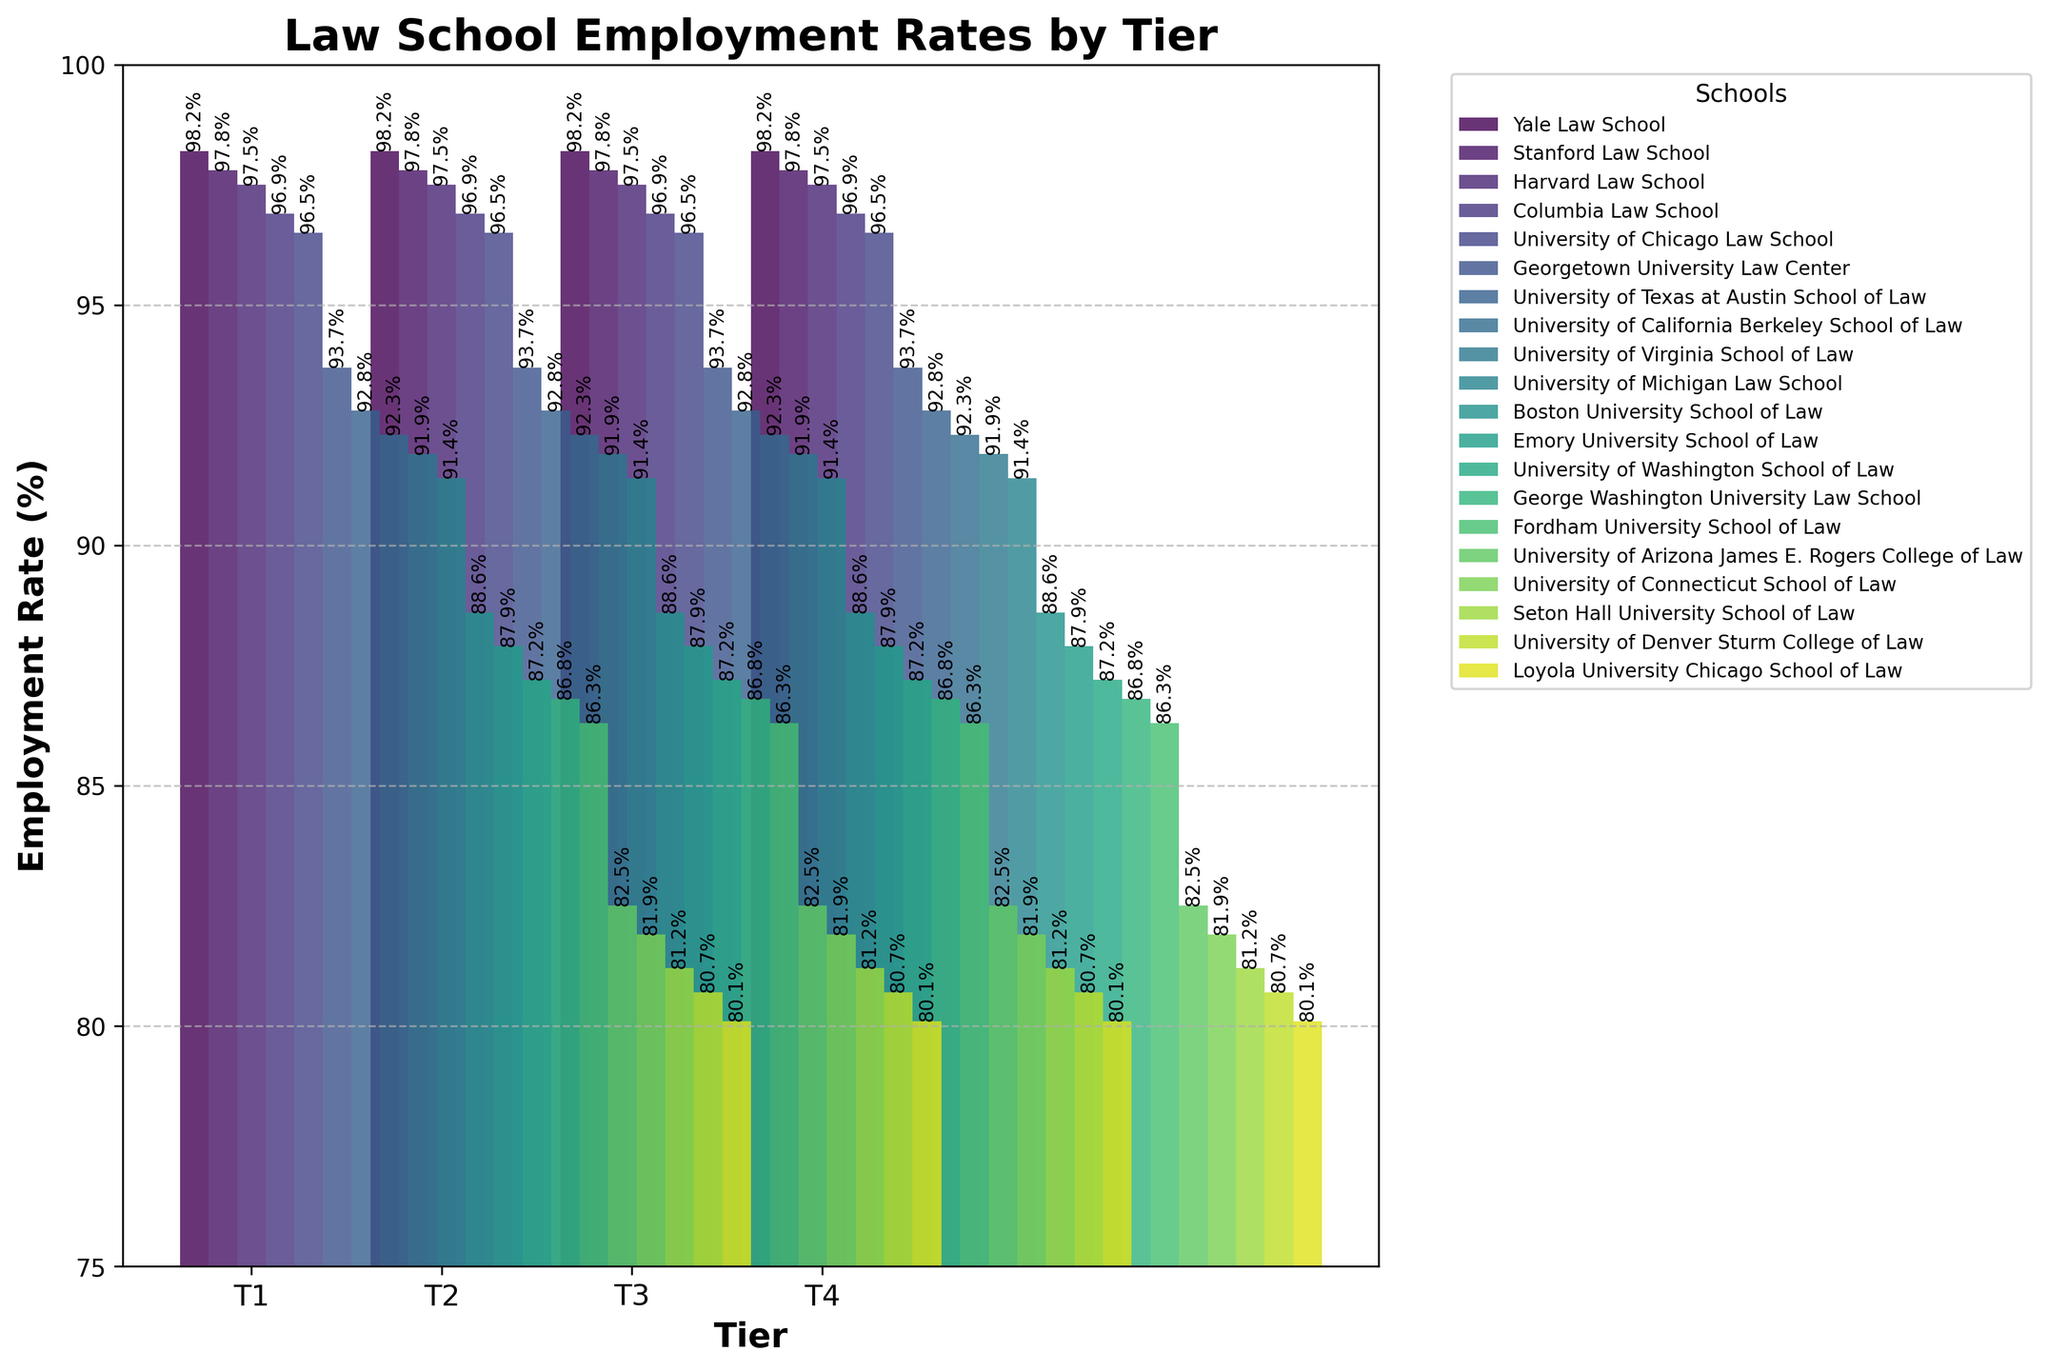What is the employment rate of Harvard Law School? Identify the bar labeled "Harvard Law School" on the x-axis under Tier 1 and read the employment rate from the y-axis.
Answer: 97.5% Which law school in Tier 2 has the highest employment rate? Look at the bars corresponding to Tier 2 and identify the tallest bar. Georgetown University Law Center has the highest employment rate in Tier 2.
Answer: Georgetown University Law Center Is the average employment rate of Tier 3 schools greater than 87%? Calculate the average employment rate of Tier 3 schools by adding their rates and dividing by the number of schools: (88.6 + 87.9 + 87.2 + 86.8 + 86.3) / 5 = 87.36. Compare this with 87%.
Answer: Yes How does the employment rate of Yale Law School compare to that of Stanford Law School? Identify the bars for Yale Law School and Stanford Law School in Tier 1 and compare their heights or the values from the y-axis. Yale Law School has a higher employment rate.
Answer: Yale Law School has a higher rate What is the range of employment rates for schools in Tier 4? Identify the lowest and highest employment rates among Tier 4 schools. The lowest rate is Loyola University Chicago School of Law (80.1) and the highest is University of Arizona James E. Rogers College of Law (82.5). The range is 82.5 - 80.1 = 2.4.
Answer: 2.4 Which tier has the most schools with an employment rate above 90%? Count the number of schools in each tier whose bars reach above the 90% mark on the y-axis. Tier 1 has all five schools above 90%, and Tier 2 has all five schools above 90%, unlike Tiers 3 and 4, which have none.
Answer: Tier 1 and Tier 2 (tie) What is the combined employment rate of Columbia Law School and University of Virginia School of Law? Add the employment rates of Columbia Law School (96.9) and University of Virginia School of Law (91.9): 96.9 + 91.9 = 188.8.
Answer: 188.8 How does the employment rate of the lowest-ranked Tier 1 school compare to the highest-ranked Tier 2 school? Identify the lowest employment rate in Tier 1 (University of Chicago Law School: 96.5) and compare it to the highest employment rate in Tier 2 (Georgetown University Law Center: 93.7). Tier 1 lowest rate is higher.
Answer: Tier 1 lowest rate is higher 